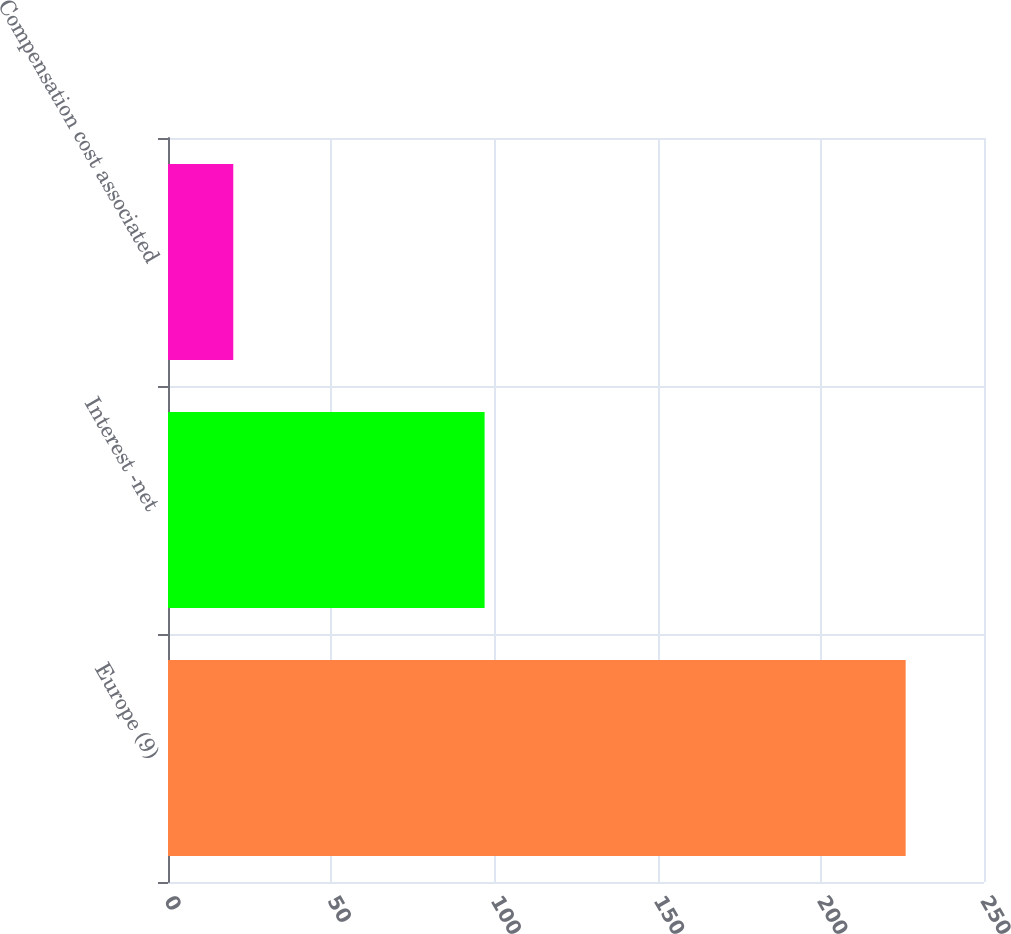Convert chart to OTSL. <chart><loc_0><loc_0><loc_500><loc_500><bar_chart><fcel>Europe (9)<fcel>Interest -net<fcel>Compensation cost associated<nl><fcel>226<fcel>97<fcel>20<nl></chart> 